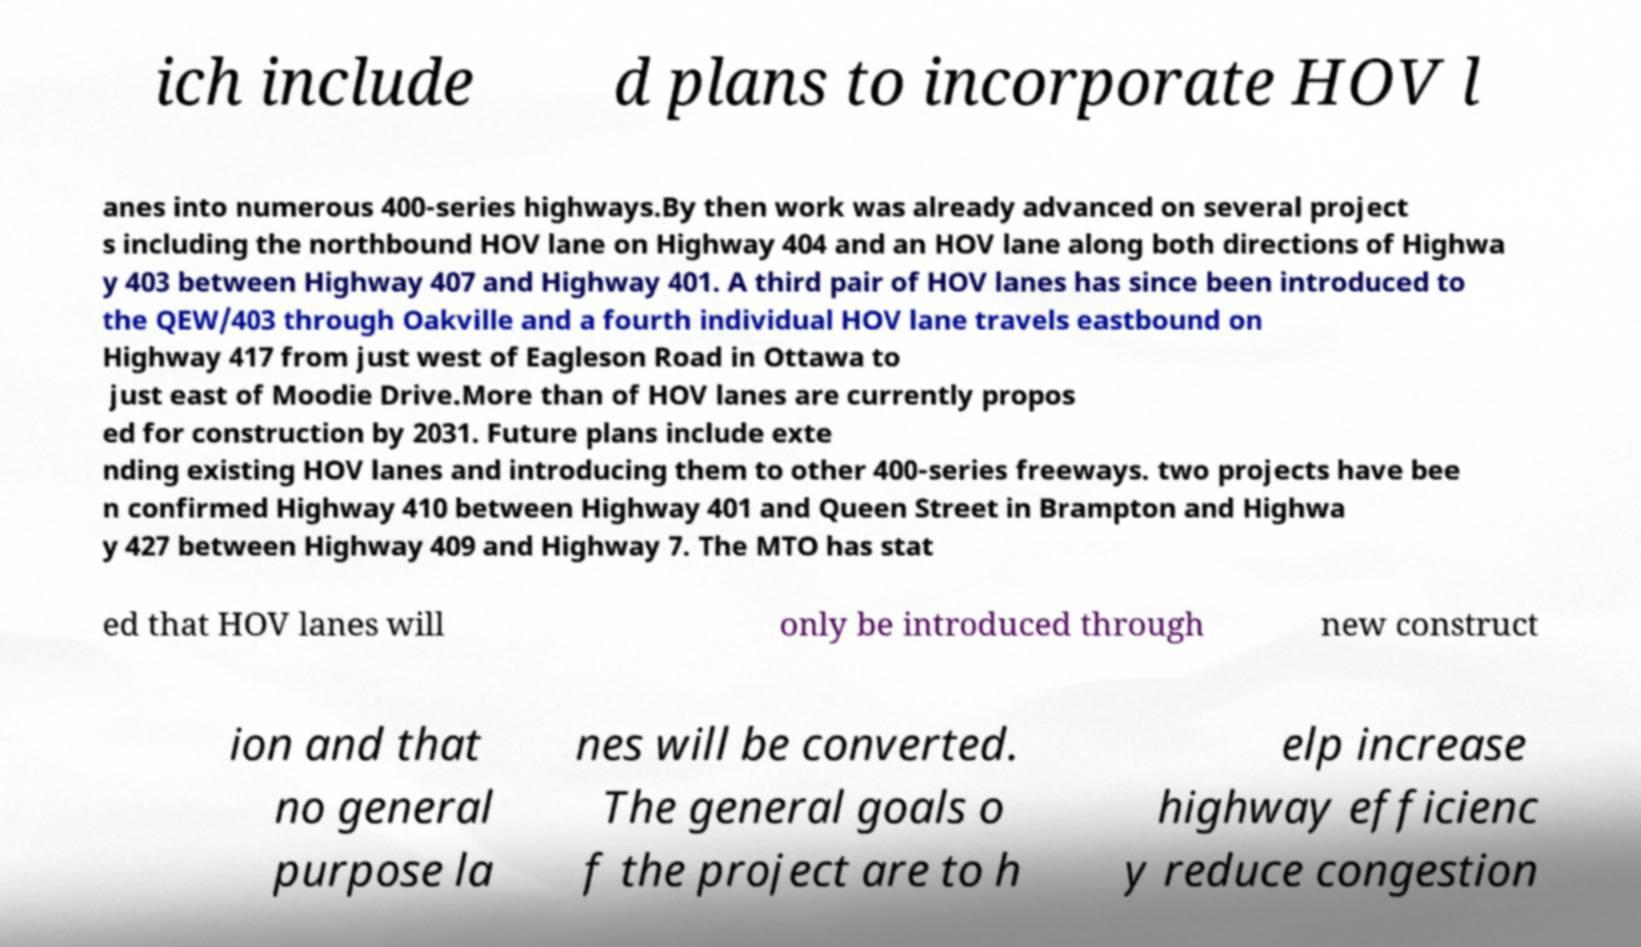Can you accurately transcribe the text from the provided image for me? ich include d plans to incorporate HOV l anes into numerous 400-series highways.By then work was already advanced on several project s including the northbound HOV lane on Highway 404 and an HOV lane along both directions of Highwa y 403 between Highway 407 and Highway 401. A third pair of HOV lanes has since been introduced to the QEW/403 through Oakville and a fourth individual HOV lane travels eastbound on Highway 417 from just west of Eagleson Road in Ottawa to just east of Moodie Drive.More than of HOV lanes are currently propos ed for construction by 2031. Future plans include exte nding existing HOV lanes and introducing them to other 400-series freeways. two projects have bee n confirmed Highway 410 between Highway 401 and Queen Street in Brampton and Highwa y 427 between Highway 409 and Highway 7. The MTO has stat ed that HOV lanes will only be introduced through new construct ion and that no general purpose la nes will be converted. The general goals o f the project are to h elp increase highway efficienc y reduce congestion 